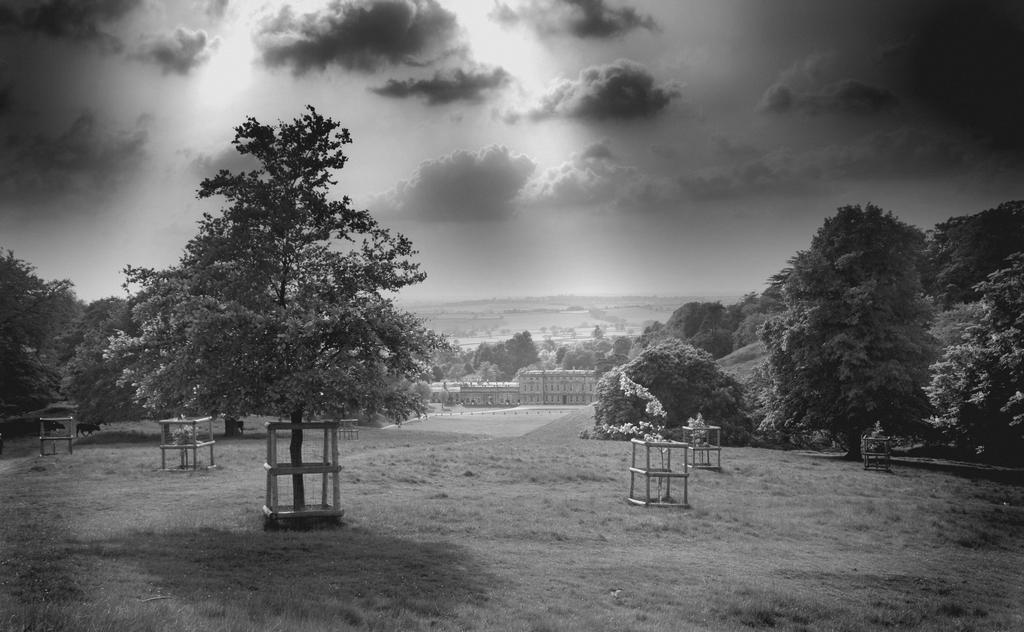Please provide a concise description of this image. This picture shows few trees and wooden fence around the plants and trees. We see buildings and a cloudy Sky. 